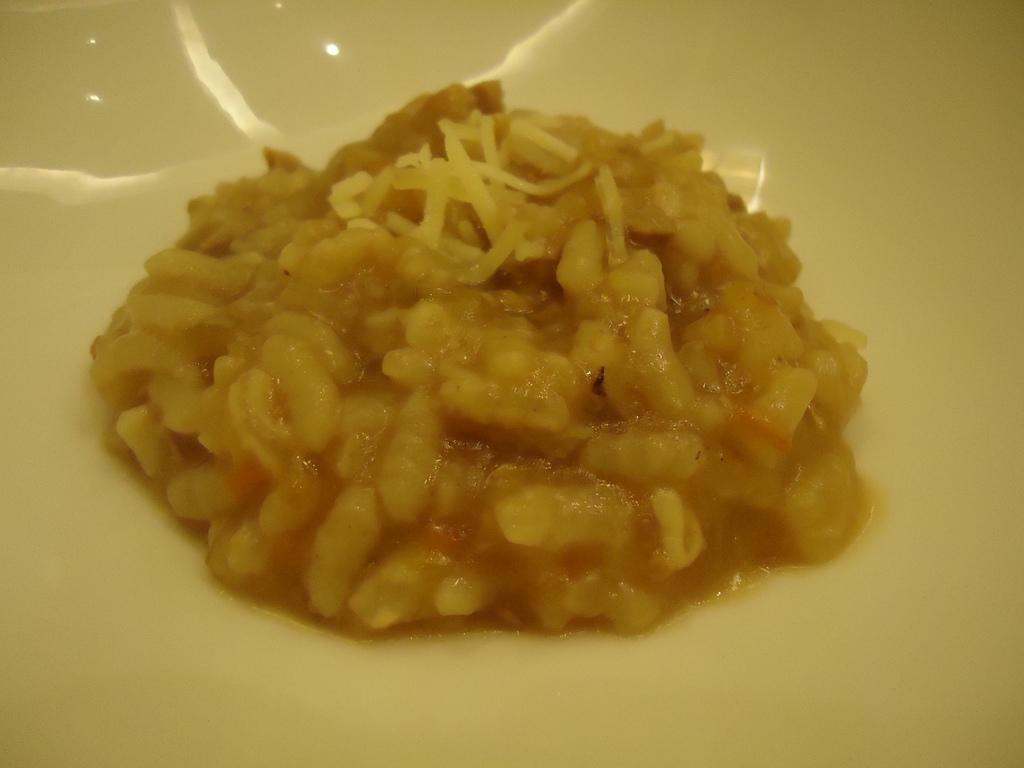What types of items can be seen in the image? There are food items in the image. Where are the food items placed? The food items are placed on a white surface. What type of bird can be seen flying over the food items in the image? There is no bird present in the image; it only features food items placed on a white surface. 